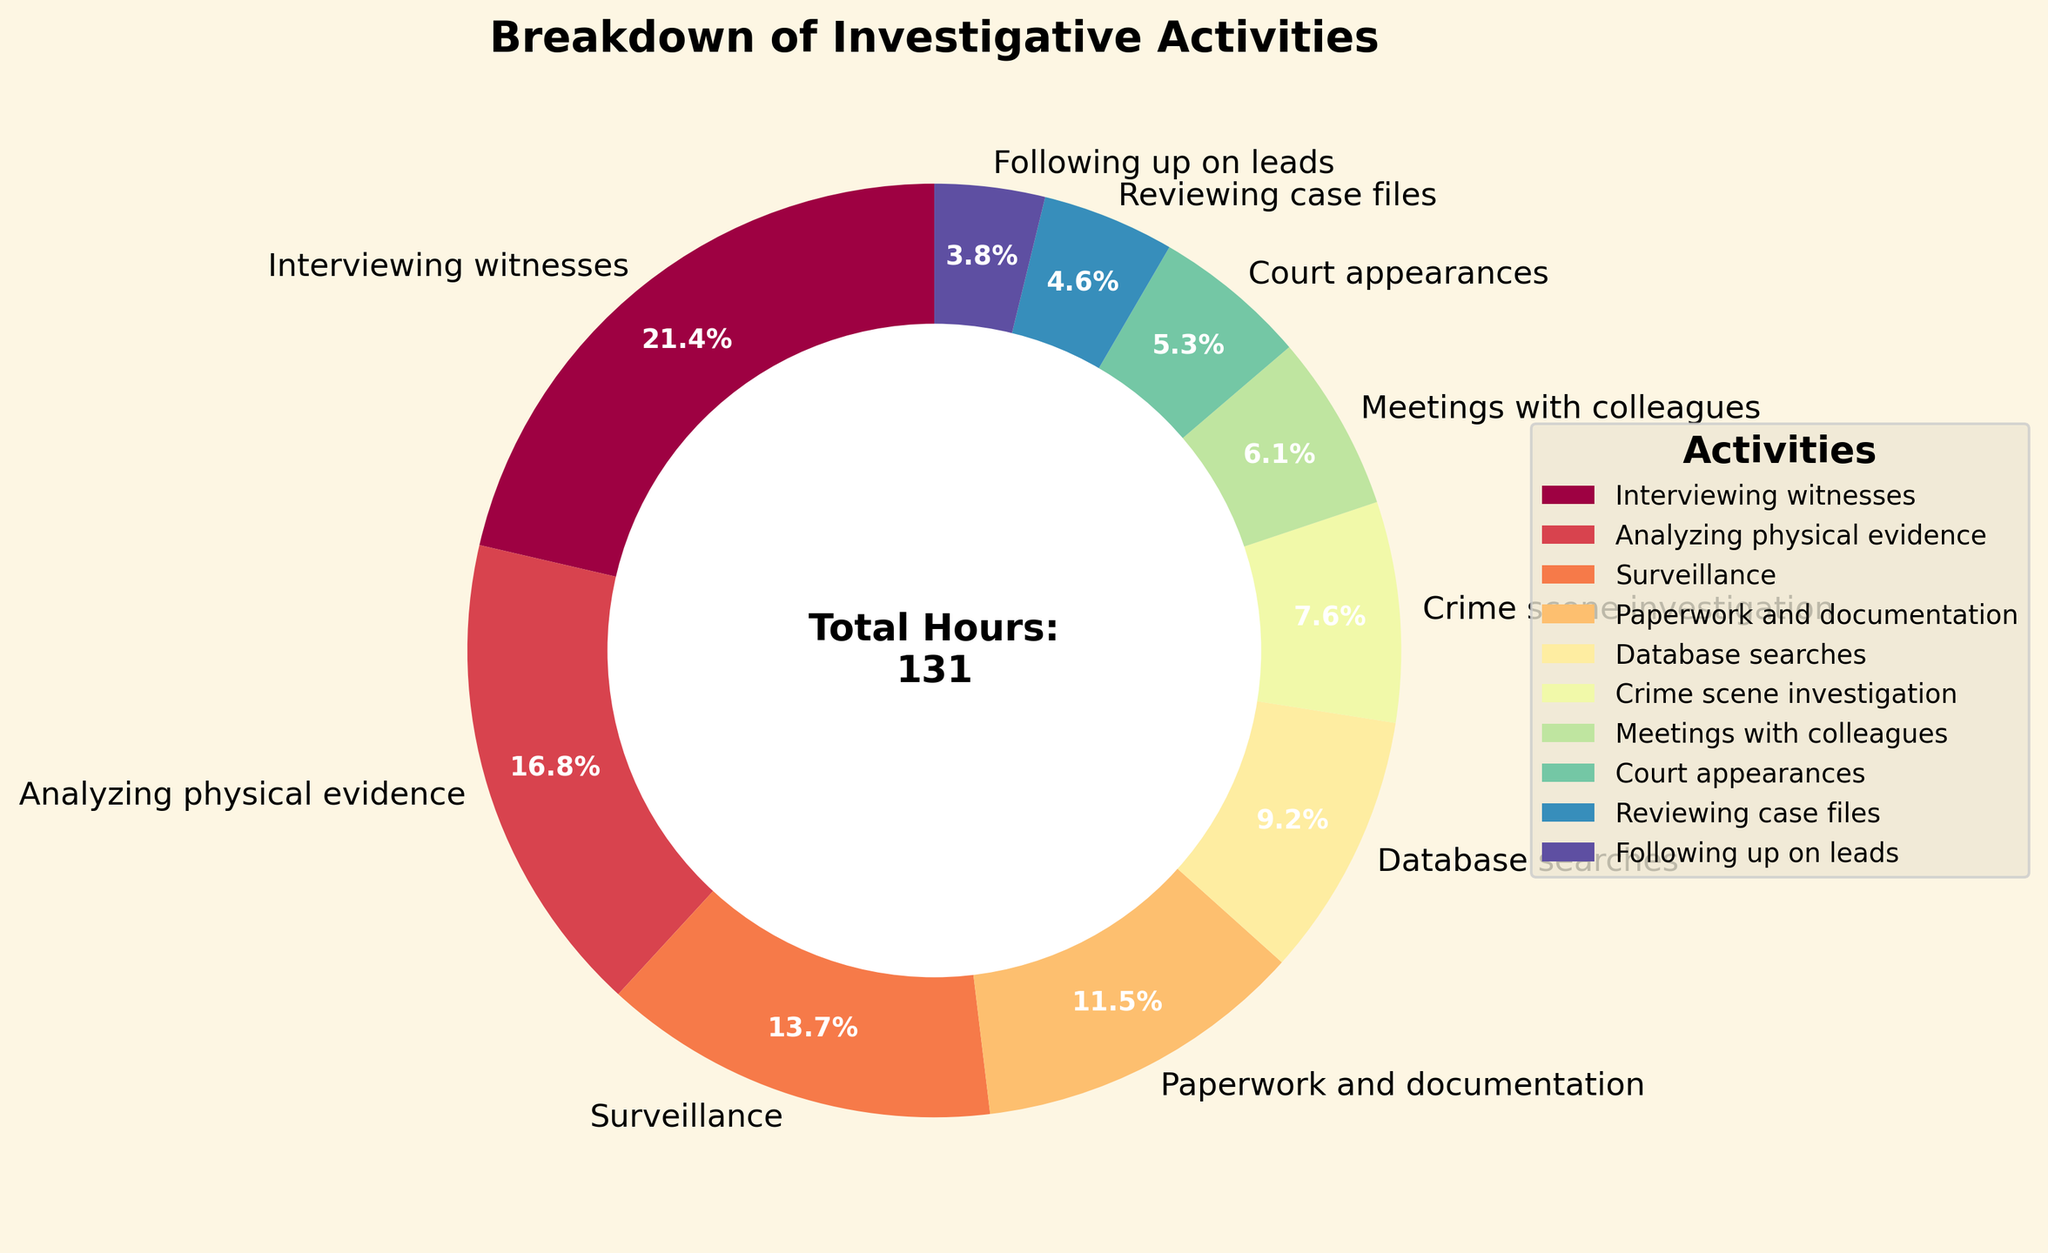What is the primary investigative activity based on the time spent? The pie chart would display "Interviewing witnesses" as the segment with the largest percentage, indicating it takes the most hours.
Answer: Interviewing witnesses What percentage of time is spent on Court appearances? Locate the "Court appearances" segment in the pie chart. The percentage is labeled.
Answer: 5.3% How much more time is spent on Interviewing witnesses compared to Following up on leads? Identify the hours for both activities from the chart. Subtract hours spent on Following up on leads from hours spent on Interviewing witnesses: 28 - 5 = 23 hours.
Answer: 23 hours Is more time spent on Surveillance or Analyzing physical evidence? Identify the segments for both activities. Compare the percentages and hours; Surveillance has 18 hours and Analyzing physical evidence has 22 hours.
Answer: Analyzing physical evidence What is the total percentage of time spent on Meetings with colleagues and Reviewing case files? Locate both segments in the pie chart and add their percentages together: (6.1% + 4.6%) = 10.7%.
Answer: 10.7% What is the least time-consuming activity? Identify the segment with the smallest percentage; "Following up on leads" has the smallest segment.
Answer: Following up on leads If the total investigative time is reduced to 100 hours proportionally, how many hours would be spent on Paperwork and documentation? Calculate the proportional time: (15 hours / 131 total hours) * 100 hours ≈ 11.5 hours.
Answer: Approximately 11.5 hours Which takes up more time, meetings with colleagues or database searches? Compare the hours for both activities in the chart; meetings with colleagues take 8 hours and database searches take 12 hours.
Answer: Database searches How many hours are spent on activities other than Interviewing witnesses, Analyzing physical evidence, and Surveillance combined? Sum the remaining hours excluding the three activities: 15 + 12 + 10 + 8 + 7 + 6 + 5 = 63 hours.
Answer: 63 hours 